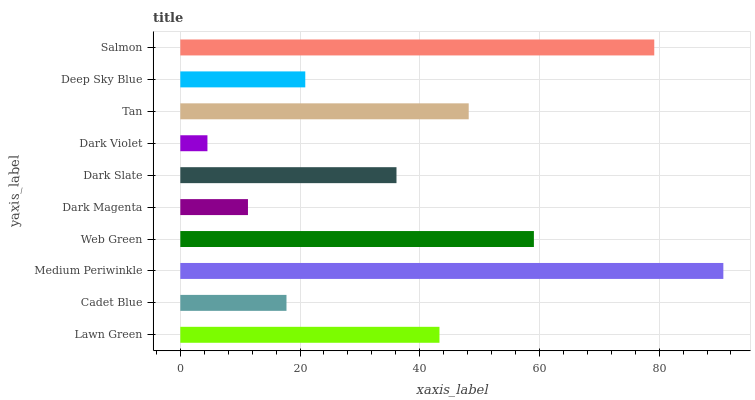Is Dark Violet the minimum?
Answer yes or no. Yes. Is Medium Periwinkle the maximum?
Answer yes or no. Yes. Is Cadet Blue the minimum?
Answer yes or no. No. Is Cadet Blue the maximum?
Answer yes or no. No. Is Lawn Green greater than Cadet Blue?
Answer yes or no. Yes. Is Cadet Blue less than Lawn Green?
Answer yes or no. Yes. Is Cadet Blue greater than Lawn Green?
Answer yes or no. No. Is Lawn Green less than Cadet Blue?
Answer yes or no. No. Is Lawn Green the high median?
Answer yes or no. Yes. Is Dark Slate the low median?
Answer yes or no. Yes. Is Deep Sky Blue the high median?
Answer yes or no. No. Is Cadet Blue the low median?
Answer yes or no. No. 